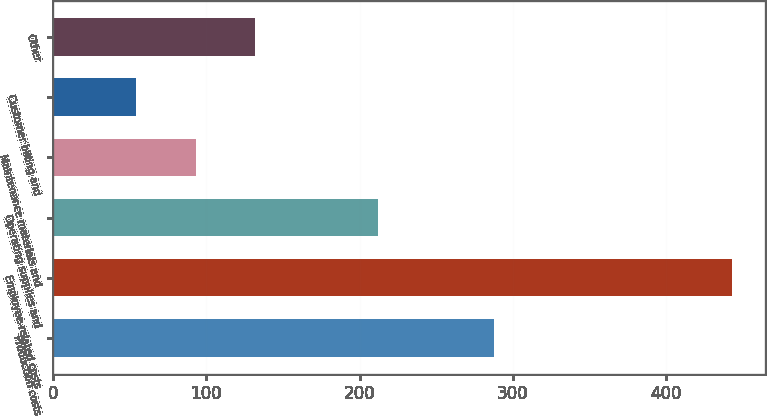<chart> <loc_0><loc_0><loc_500><loc_500><bar_chart><fcel>Production costs<fcel>Employee-related costs<fcel>Operating supplies and<fcel>Maintenance materials and<fcel>Customer billing and<fcel>Other<nl><fcel>288<fcel>443<fcel>212<fcel>92.9<fcel>54<fcel>131.8<nl></chart> 